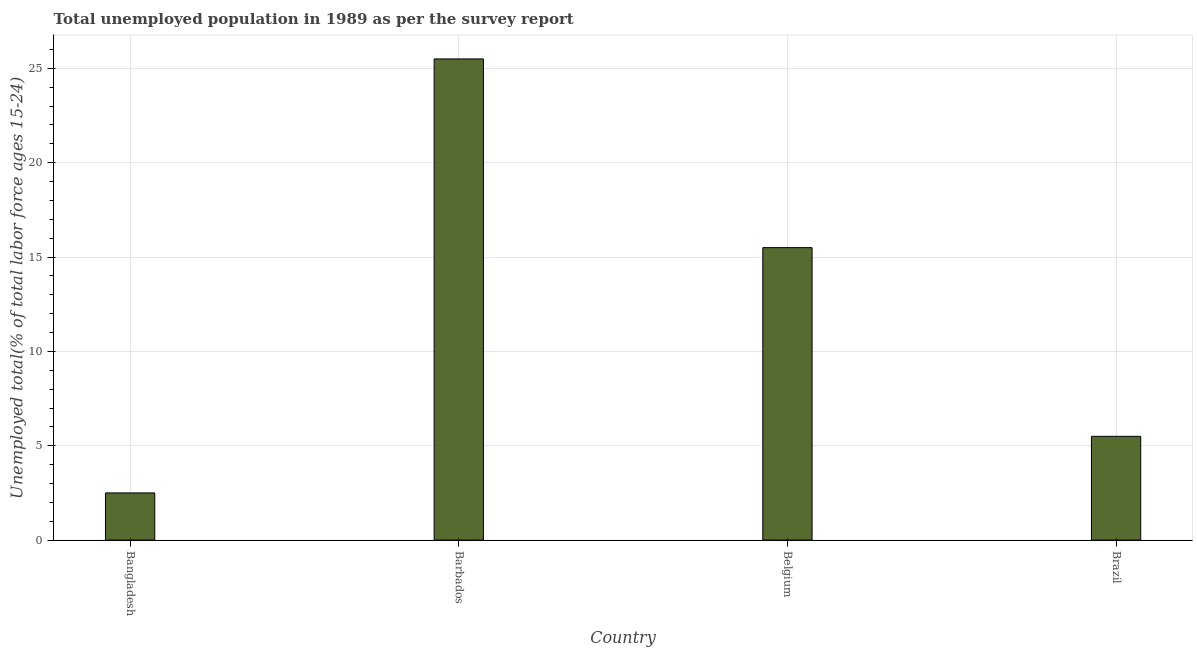Does the graph contain grids?
Provide a short and direct response. Yes. What is the title of the graph?
Your answer should be compact. Total unemployed population in 1989 as per the survey report. What is the label or title of the X-axis?
Offer a terse response. Country. What is the label or title of the Y-axis?
Your answer should be very brief. Unemployed total(% of total labor force ages 15-24). Across all countries, what is the maximum unemployed youth?
Provide a short and direct response. 25.5. In which country was the unemployed youth maximum?
Your answer should be compact. Barbados. What is the difference between the unemployed youth in Belgium and Brazil?
Your answer should be very brief. 10. What is the average unemployed youth per country?
Your response must be concise. 12.25. What is the ratio of the unemployed youth in Bangladesh to that in Belgium?
Give a very brief answer. 0.16. Is the unemployed youth in Barbados less than that in Brazil?
Provide a succinct answer. No. Is the difference between the unemployed youth in Barbados and Brazil greater than the difference between any two countries?
Make the answer very short. No. Is the sum of the unemployed youth in Barbados and Belgium greater than the maximum unemployed youth across all countries?
Keep it short and to the point. Yes. What is the difference between the highest and the lowest unemployed youth?
Offer a very short reply. 23. How many bars are there?
Provide a succinct answer. 4. What is the difference between two consecutive major ticks on the Y-axis?
Keep it short and to the point. 5. What is the Unemployed total(% of total labor force ages 15-24) of Barbados?
Ensure brevity in your answer.  25.5. What is the Unemployed total(% of total labor force ages 15-24) in Belgium?
Your answer should be very brief. 15.5. What is the difference between the Unemployed total(% of total labor force ages 15-24) in Bangladesh and Brazil?
Provide a succinct answer. -3. What is the ratio of the Unemployed total(% of total labor force ages 15-24) in Bangladesh to that in Barbados?
Offer a very short reply. 0.1. What is the ratio of the Unemployed total(% of total labor force ages 15-24) in Bangladesh to that in Belgium?
Your answer should be very brief. 0.16. What is the ratio of the Unemployed total(% of total labor force ages 15-24) in Bangladesh to that in Brazil?
Give a very brief answer. 0.46. What is the ratio of the Unemployed total(% of total labor force ages 15-24) in Barbados to that in Belgium?
Your answer should be compact. 1.65. What is the ratio of the Unemployed total(% of total labor force ages 15-24) in Barbados to that in Brazil?
Make the answer very short. 4.64. What is the ratio of the Unemployed total(% of total labor force ages 15-24) in Belgium to that in Brazil?
Offer a very short reply. 2.82. 